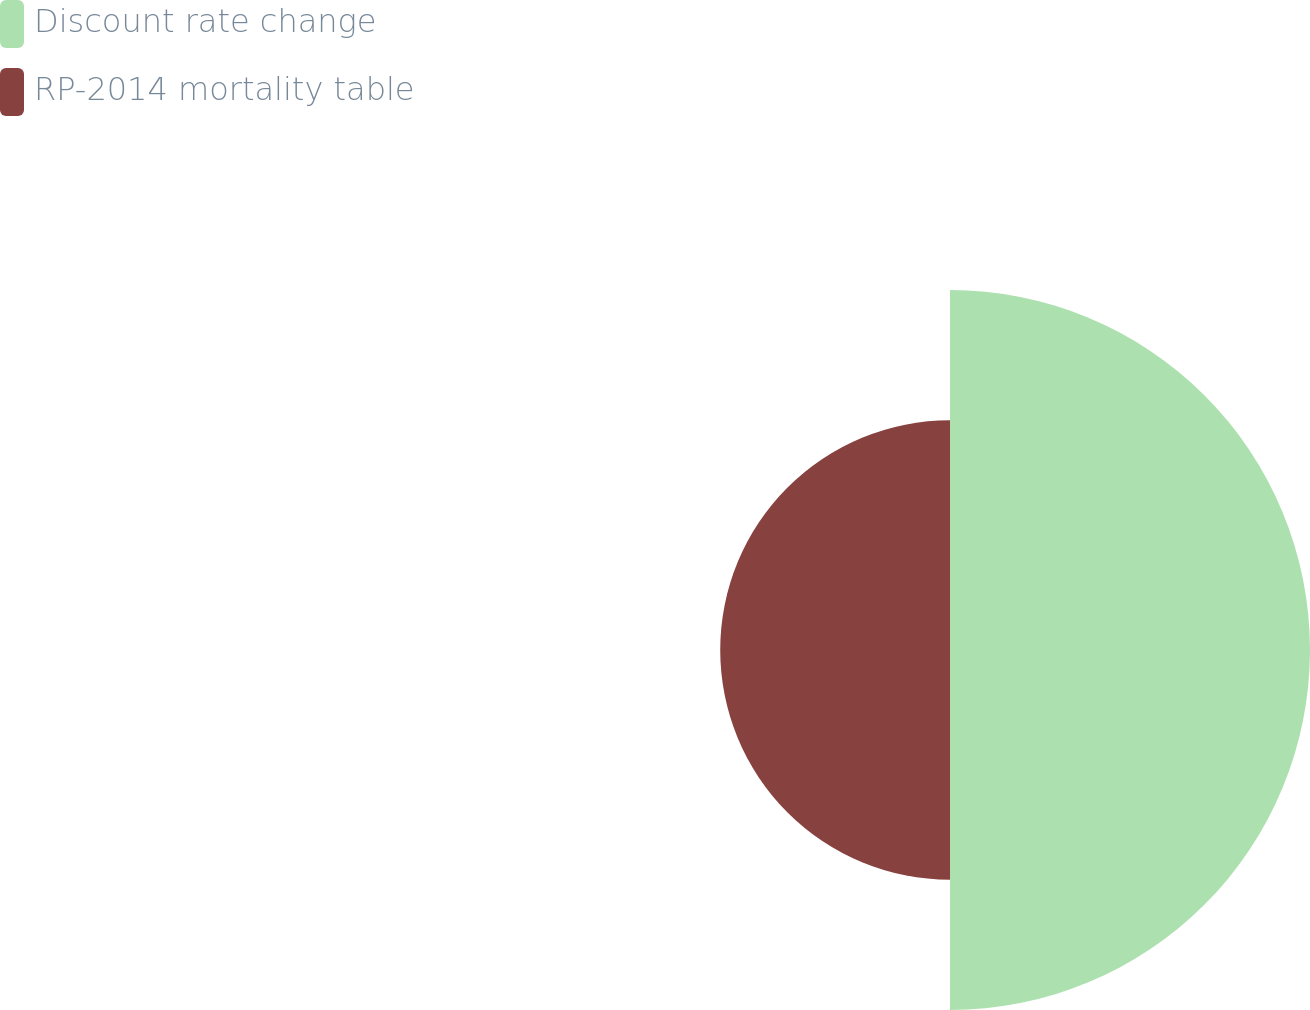<chart> <loc_0><loc_0><loc_500><loc_500><pie_chart><fcel>Discount rate change<fcel>RP-2014 mortality table<nl><fcel>61.04%<fcel>38.96%<nl></chart> 